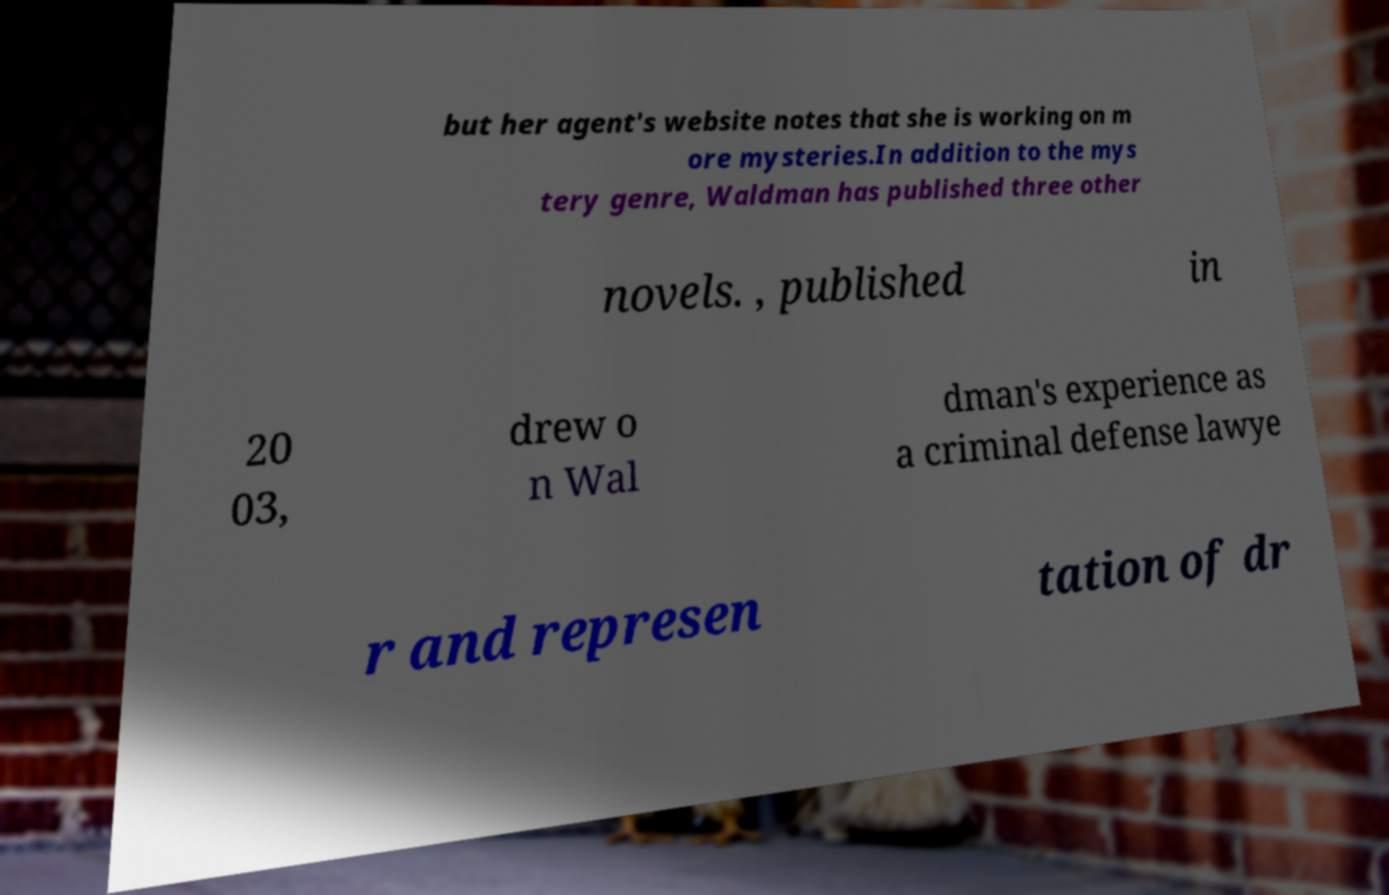Could you assist in decoding the text presented in this image and type it out clearly? but her agent's website notes that she is working on m ore mysteries.In addition to the mys tery genre, Waldman has published three other novels. , published in 20 03, drew o n Wal dman's experience as a criminal defense lawye r and represen tation of dr 